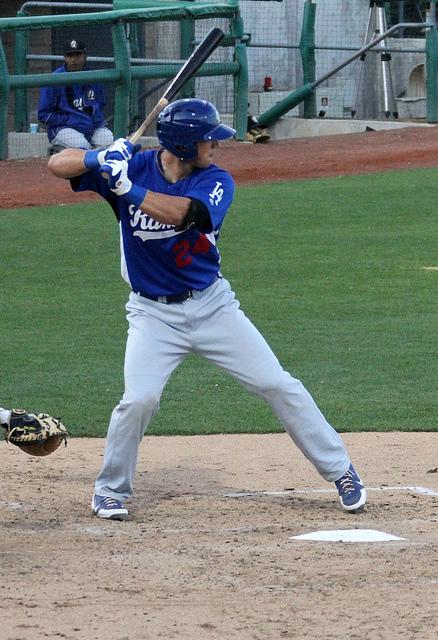Which leg does the batter have forward?
Short answer required. Left. What color is the man's uniform?
Quick response, please. Blue. Is this person pitching a ball?
Give a very brief answer. No. What sport is this?
Be succinct. Baseball. What color is the shirt the man is wearing?
Be succinct. Blue. Is the batter a child or an adult?
Short answer required. Adult. What color is the bat?
Give a very brief answer. Black. What is the man about to do?
Short answer required. Hit baseball. What team does this person play for?
Keep it brief. Royals. What position is this player playing?
Quick response, please. Batter. Does the man have a ball in his hand?
Concise answer only. No. Does this player have special shoes?
Short answer required. Yes. 